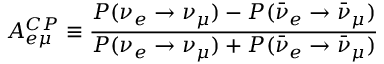Convert formula to latex. <formula><loc_0><loc_0><loc_500><loc_500>A _ { e \mu } ^ { C P } \equiv \frac { P ( \nu _ { e } \rightarrow \nu _ { \mu } ) - P ( \bar { \nu } _ { e } \rightarrow \bar { \nu } _ { \mu } ) } { P ( \nu _ { e } \rightarrow \nu _ { \mu } ) + P ( \bar { \nu } _ { e } \rightarrow \bar { \nu } _ { \mu } ) } \,</formula> 